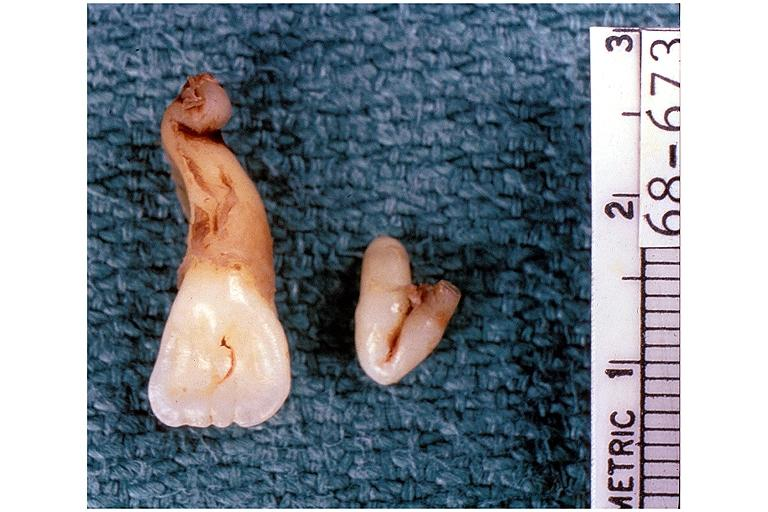what is present?
Answer the question using a single word or phrase. Oral 